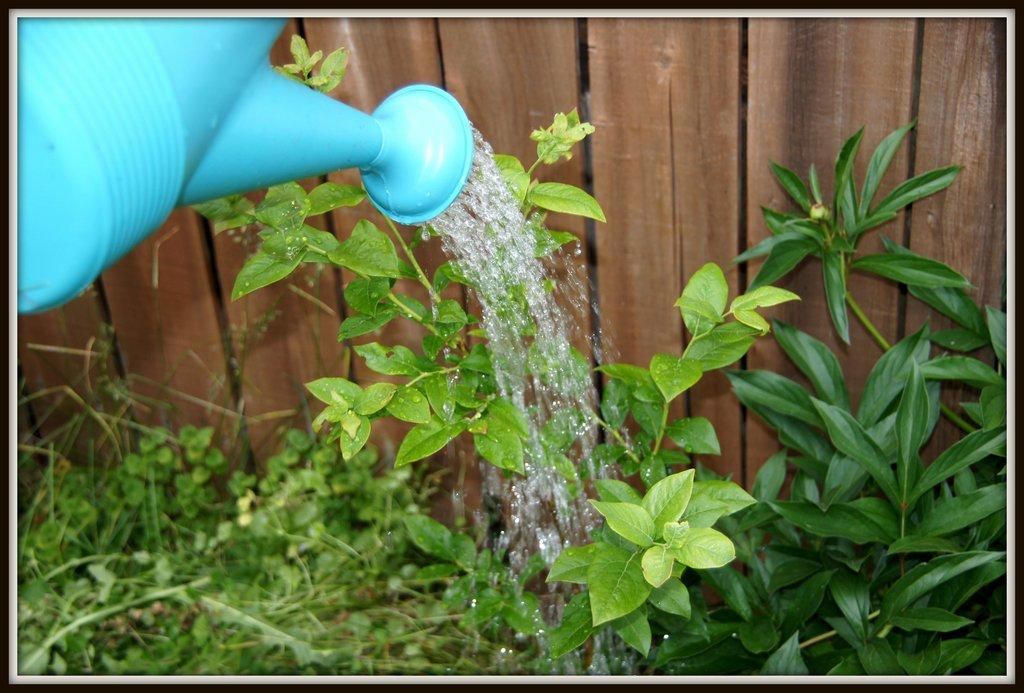What color is the watering pot in the image? The watering pot in the image is blue. What else can be seen in the image besides the watering pot? There are plants visible in the image. What is in the background of the image? There is a wooden fence in the background of the image. What caption is written on the watering pot in the image? There is no caption written on the watering pot in the image; it is a plain blue watering pot. 